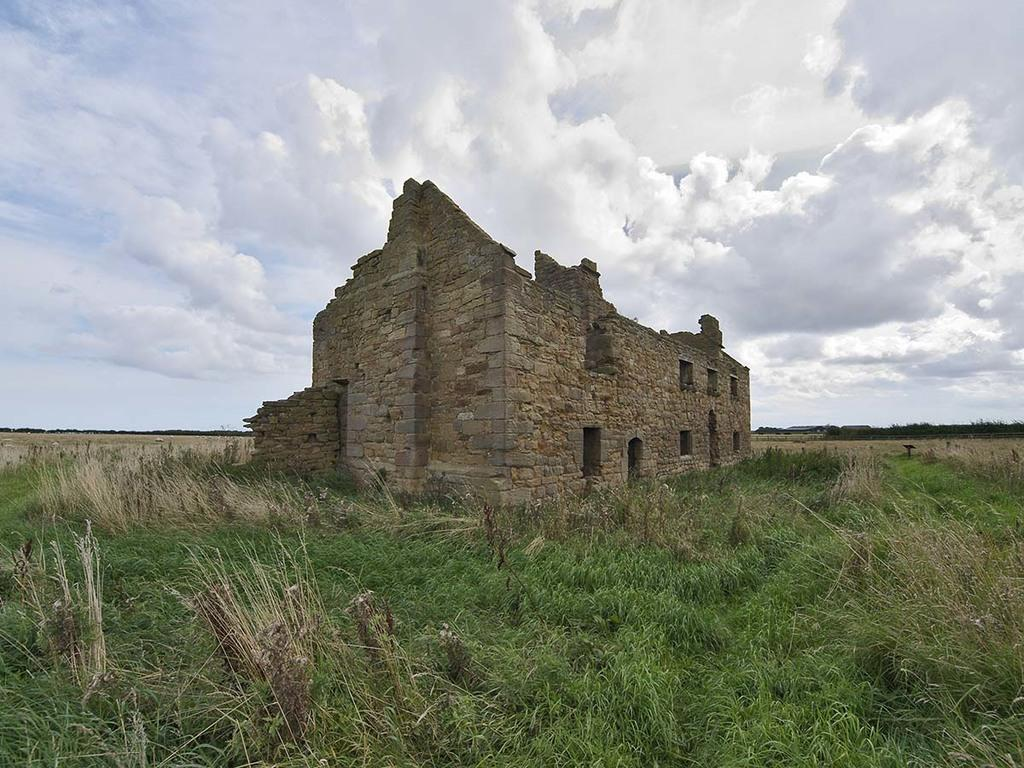What type of landscape is depicted in the image? There is a field in the image. What structure can be seen in the middle of the field? There is a fort in the middle of the field. What is visible in the background of the image? The sky is visible in the background of the image. How would you describe the weather based on the appearance of the sky? The sky appears to be cloudy, which might suggest overcast or potentially rainy weather. How many shoes are being blown away by the wind in the image? There are no shoes present in the image, nor is there any wind blowing anything away. 